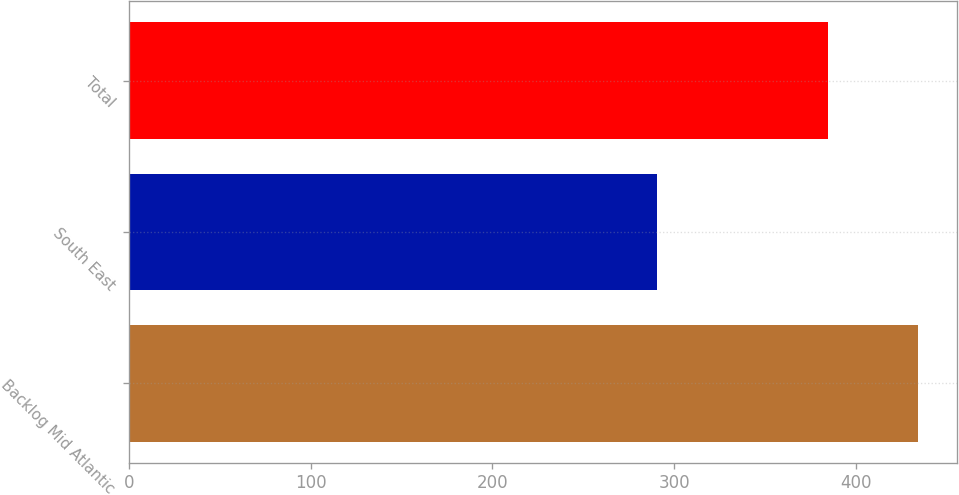Convert chart. <chart><loc_0><loc_0><loc_500><loc_500><bar_chart><fcel>Backlog Mid Atlantic<fcel>South East<fcel>Total<nl><fcel>434.2<fcel>290.7<fcel>384.6<nl></chart> 